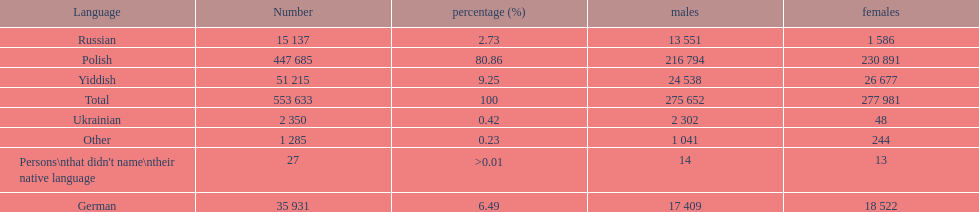Which language did the most people in the imperial census of 1897 speak in the p&#322;ock governorate? Polish. 